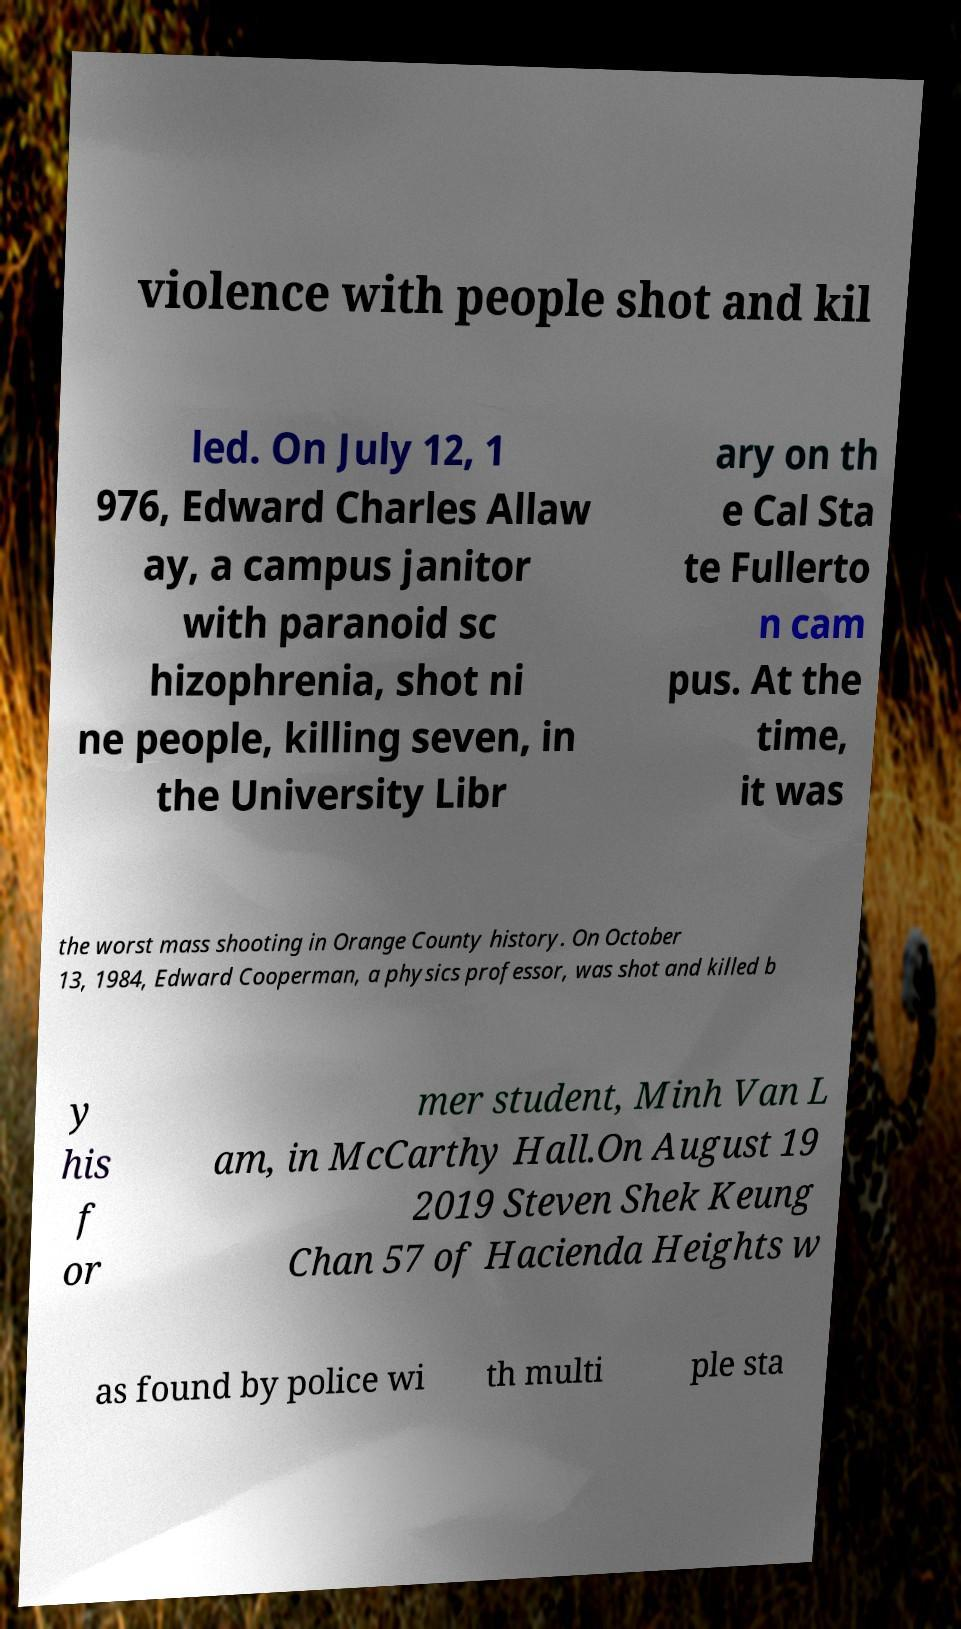Could you extract and type out the text from this image? violence with people shot and kil led. On July 12, 1 976, Edward Charles Allaw ay, a campus janitor with paranoid sc hizophrenia, shot ni ne people, killing seven, in the University Libr ary on th e Cal Sta te Fullerto n cam pus. At the time, it was the worst mass shooting in Orange County history. On October 13, 1984, Edward Cooperman, a physics professor, was shot and killed b y his f or mer student, Minh Van L am, in McCarthy Hall.On August 19 2019 Steven Shek Keung Chan 57 of Hacienda Heights w as found by police wi th multi ple sta 